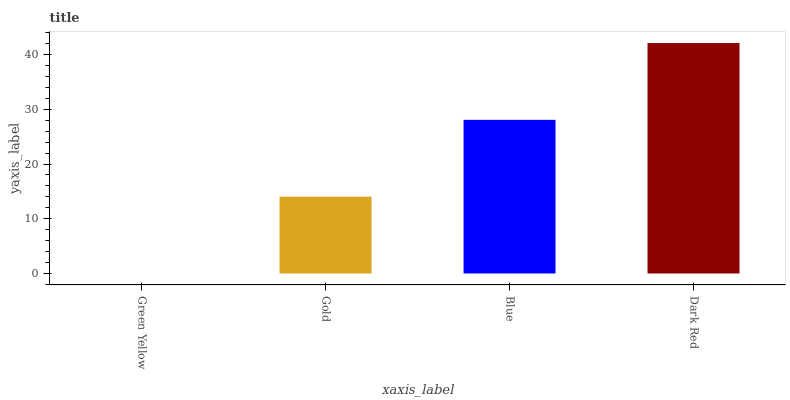Is Green Yellow the minimum?
Answer yes or no. Yes. Is Dark Red the maximum?
Answer yes or no. Yes. Is Gold the minimum?
Answer yes or no. No. Is Gold the maximum?
Answer yes or no. No. Is Gold greater than Green Yellow?
Answer yes or no. Yes. Is Green Yellow less than Gold?
Answer yes or no. Yes. Is Green Yellow greater than Gold?
Answer yes or no. No. Is Gold less than Green Yellow?
Answer yes or no. No. Is Blue the high median?
Answer yes or no. Yes. Is Gold the low median?
Answer yes or no. Yes. Is Green Yellow the high median?
Answer yes or no. No. Is Dark Red the low median?
Answer yes or no. No. 